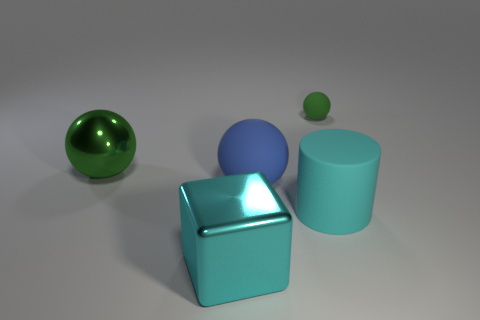Are there any other things that have the same size as the green matte object?
Provide a short and direct response. No. There is a block in front of the big blue thing; how many big things are left of it?
Your answer should be compact. 1. What is the big object that is behind the cyan rubber cylinder and to the right of the large green metallic thing made of?
Your answer should be very brief. Rubber. There is a cyan object to the left of the blue ball; does it have the same shape as the small green matte thing?
Your answer should be very brief. No. Are there fewer big purple objects than big blue things?
Your answer should be very brief. Yes. What number of big metallic balls have the same color as the rubber cylinder?
Offer a terse response. 0. There is a big object that is the same color as the big rubber cylinder; what is it made of?
Offer a very short reply. Metal. There is a small matte sphere; is it the same color as the rubber sphere in front of the small green ball?
Make the answer very short. No. Is the number of small brown shiny spheres greater than the number of big metallic cubes?
Ensure brevity in your answer.  No. What size is the other green object that is the same shape as the green rubber thing?
Make the answer very short. Large. 